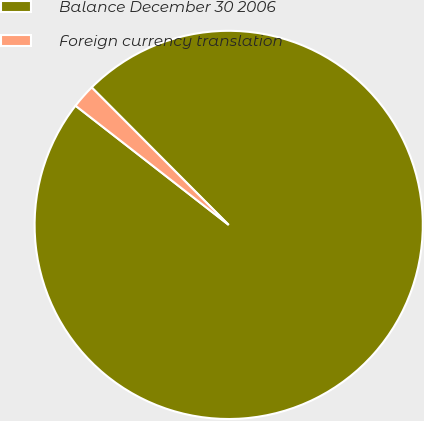<chart> <loc_0><loc_0><loc_500><loc_500><pie_chart><fcel>Balance December 30 2006<fcel>Foreign currency translation<nl><fcel>98.0%<fcel>2.0%<nl></chart> 